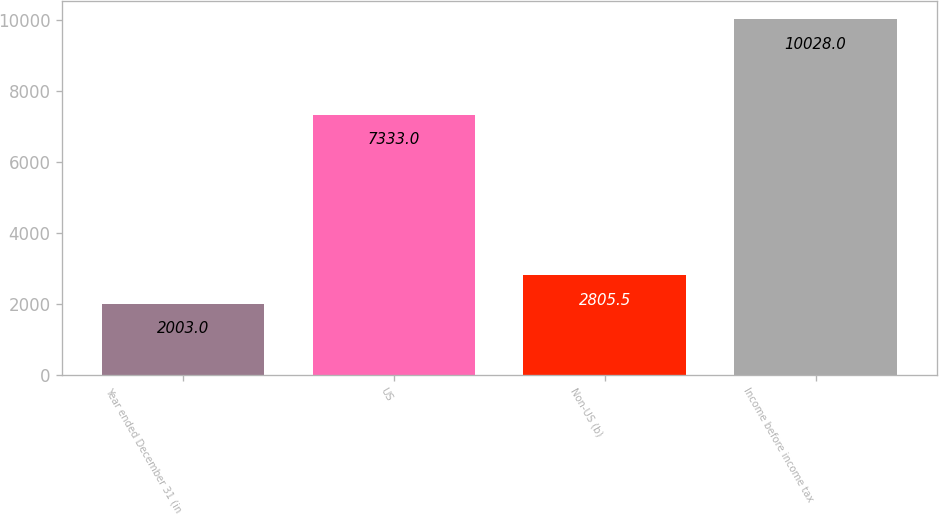<chart> <loc_0><loc_0><loc_500><loc_500><bar_chart><fcel>Year ended December 31 (in<fcel>US<fcel>Non-US (b)<fcel>Income before income tax<nl><fcel>2003<fcel>7333<fcel>2805.5<fcel>10028<nl></chart> 